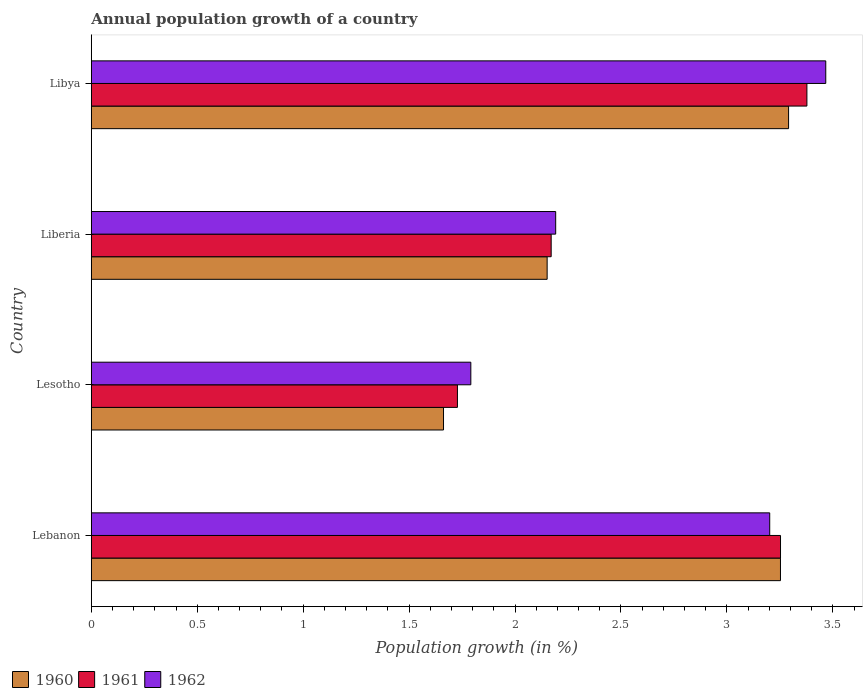How many groups of bars are there?
Your response must be concise. 4. Are the number of bars on each tick of the Y-axis equal?
Your answer should be very brief. Yes. How many bars are there on the 3rd tick from the top?
Keep it short and to the point. 3. What is the label of the 1st group of bars from the top?
Your response must be concise. Libya. In how many cases, is the number of bars for a given country not equal to the number of legend labels?
Your answer should be very brief. 0. What is the annual population growth in 1962 in Libya?
Keep it short and to the point. 3.47. Across all countries, what is the maximum annual population growth in 1961?
Offer a terse response. 3.38. Across all countries, what is the minimum annual population growth in 1961?
Give a very brief answer. 1.73. In which country was the annual population growth in 1961 maximum?
Give a very brief answer. Libya. In which country was the annual population growth in 1961 minimum?
Offer a very short reply. Lesotho. What is the total annual population growth in 1960 in the graph?
Provide a short and direct response. 10.36. What is the difference between the annual population growth in 1962 in Lebanon and that in Liberia?
Provide a succinct answer. 1.01. What is the difference between the annual population growth in 1961 in Liberia and the annual population growth in 1962 in Libya?
Keep it short and to the point. -1.3. What is the average annual population growth in 1962 per country?
Offer a terse response. 2.66. What is the difference between the annual population growth in 1961 and annual population growth in 1960 in Liberia?
Ensure brevity in your answer.  0.02. What is the ratio of the annual population growth in 1960 in Lesotho to that in Libya?
Offer a very short reply. 0.51. Is the difference between the annual population growth in 1961 in Lebanon and Liberia greater than the difference between the annual population growth in 1960 in Lebanon and Liberia?
Offer a terse response. No. What is the difference between the highest and the second highest annual population growth in 1960?
Provide a short and direct response. 0.04. What is the difference between the highest and the lowest annual population growth in 1960?
Your response must be concise. 1.63. In how many countries, is the annual population growth in 1961 greater than the average annual population growth in 1961 taken over all countries?
Your answer should be compact. 2. Is the sum of the annual population growth in 1962 in Lebanon and Liberia greater than the maximum annual population growth in 1961 across all countries?
Provide a short and direct response. Yes. What does the 3rd bar from the bottom in Libya represents?
Your answer should be very brief. 1962. Is it the case that in every country, the sum of the annual population growth in 1962 and annual population growth in 1960 is greater than the annual population growth in 1961?
Provide a short and direct response. Yes. How many bars are there?
Your answer should be compact. 12. Are all the bars in the graph horizontal?
Provide a short and direct response. Yes. Are the values on the major ticks of X-axis written in scientific E-notation?
Give a very brief answer. No. Does the graph contain any zero values?
Your answer should be compact. No. Does the graph contain grids?
Provide a succinct answer. No. Where does the legend appear in the graph?
Give a very brief answer. Bottom left. How are the legend labels stacked?
Your response must be concise. Horizontal. What is the title of the graph?
Give a very brief answer. Annual population growth of a country. What is the label or title of the X-axis?
Provide a succinct answer. Population growth (in %). What is the label or title of the Y-axis?
Your answer should be compact. Country. What is the Population growth (in %) of 1960 in Lebanon?
Offer a terse response. 3.25. What is the Population growth (in %) of 1961 in Lebanon?
Your response must be concise. 3.25. What is the Population growth (in %) of 1962 in Lebanon?
Your response must be concise. 3.2. What is the Population growth (in %) in 1960 in Lesotho?
Make the answer very short. 1.66. What is the Population growth (in %) of 1961 in Lesotho?
Your response must be concise. 1.73. What is the Population growth (in %) in 1962 in Lesotho?
Offer a very short reply. 1.79. What is the Population growth (in %) in 1960 in Liberia?
Give a very brief answer. 2.15. What is the Population growth (in %) of 1961 in Liberia?
Provide a succinct answer. 2.17. What is the Population growth (in %) in 1962 in Liberia?
Your answer should be very brief. 2.19. What is the Population growth (in %) in 1960 in Libya?
Give a very brief answer. 3.29. What is the Population growth (in %) of 1961 in Libya?
Offer a terse response. 3.38. What is the Population growth (in %) in 1962 in Libya?
Offer a terse response. 3.47. Across all countries, what is the maximum Population growth (in %) in 1960?
Offer a terse response. 3.29. Across all countries, what is the maximum Population growth (in %) of 1961?
Your response must be concise. 3.38. Across all countries, what is the maximum Population growth (in %) of 1962?
Provide a succinct answer. 3.47. Across all countries, what is the minimum Population growth (in %) in 1960?
Your response must be concise. 1.66. Across all countries, what is the minimum Population growth (in %) in 1961?
Ensure brevity in your answer.  1.73. Across all countries, what is the minimum Population growth (in %) of 1962?
Your response must be concise. 1.79. What is the total Population growth (in %) of 1960 in the graph?
Your answer should be compact. 10.36. What is the total Population growth (in %) in 1961 in the graph?
Keep it short and to the point. 10.53. What is the total Population growth (in %) in 1962 in the graph?
Your answer should be compact. 10.65. What is the difference between the Population growth (in %) of 1960 in Lebanon and that in Lesotho?
Your answer should be compact. 1.59. What is the difference between the Population growth (in %) of 1961 in Lebanon and that in Lesotho?
Ensure brevity in your answer.  1.52. What is the difference between the Population growth (in %) in 1962 in Lebanon and that in Lesotho?
Provide a succinct answer. 1.41. What is the difference between the Population growth (in %) in 1960 in Lebanon and that in Liberia?
Your answer should be very brief. 1.1. What is the difference between the Population growth (in %) of 1961 in Lebanon and that in Liberia?
Give a very brief answer. 1.08. What is the difference between the Population growth (in %) of 1962 in Lebanon and that in Liberia?
Offer a terse response. 1.01. What is the difference between the Population growth (in %) of 1960 in Lebanon and that in Libya?
Ensure brevity in your answer.  -0.04. What is the difference between the Population growth (in %) of 1961 in Lebanon and that in Libya?
Provide a succinct answer. -0.12. What is the difference between the Population growth (in %) of 1962 in Lebanon and that in Libya?
Keep it short and to the point. -0.26. What is the difference between the Population growth (in %) of 1960 in Lesotho and that in Liberia?
Your response must be concise. -0.49. What is the difference between the Population growth (in %) of 1961 in Lesotho and that in Liberia?
Offer a terse response. -0.44. What is the difference between the Population growth (in %) in 1962 in Lesotho and that in Liberia?
Provide a succinct answer. -0.4. What is the difference between the Population growth (in %) of 1960 in Lesotho and that in Libya?
Provide a short and direct response. -1.63. What is the difference between the Population growth (in %) of 1961 in Lesotho and that in Libya?
Offer a very short reply. -1.65. What is the difference between the Population growth (in %) of 1962 in Lesotho and that in Libya?
Your answer should be very brief. -1.68. What is the difference between the Population growth (in %) in 1960 in Liberia and that in Libya?
Give a very brief answer. -1.14. What is the difference between the Population growth (in %) in 1961 in Liberia and that in Libya?
Provide a short and direct response. -1.21. What is the difference between the Population growth (in %) in 1962 in Liberia and that in Libya?
Offer a very short reply. -1.27. What is the difference between the Population growth (in %) in 1960 in Lebanon and the Population growth (in %) in 1961 in Lesotho?
Give a very brief answer. 1.52. What is the difference between the Population growth (in %) of 1960 in Lebanon and the Population growth (in %) of 1962 in Lesotho?
Offer a very short reply. 1.46. What is the difference between the Population growth (in %) of 1961 in Lebanon and the Population growth (in %) of 1962 in Lesotho?
Ensure brevity in your answer.  1.46. What is the difference between the Population growth (in %) in 1960 in Lebanon and the Population growth (in %) in 1961 in Liberia?
Offer a terse response. 1.08. What is the difference between the Population growth (in %) in 1960 in Lebanon and the Population growth (in %) in 1962 in Liberia?
Give a very brief answer. 1.06. What is the difference between the Population growth (in %) in 1961 in Lebanon and the Population growth (in %) in 1962 in Liberia?
Offer a very short reply. 1.06. What is the difference between the Population growth (in %) in 1960 in Lebanon and the Population growth (in %) in 1961 in Libya?
Make the answer very short. -0.12. What is the difference between the Population growth (in %) in 1960 in Lebanon and the Population growth (in %) in 1962 in Libya?
Your answer should be compact. -0.21. What is the difference between the Population growth (in %) of 1961 in Lebanon and the Population growth (in %) of 1962 in Libya?
Make the answer very short. -0.21. What is the difference between the Population growth (in %) of 1960 in Lesotho and the Population growth (in %) of 1961 in Liberia?
Your answer should be compact. -0.51. What is the difference between the Population growth (in %) in 1960 in Lesotho and the Population growth (in %) in 1962 in Liberia?
Ensure brevity in your answer.  -0.53. What is the difference between the Population growth (in %) of 1961 in Lesotho and the Population growth (in %) of 1962 in Liberia?
Give a very brief answer. -0.46. What is the difference between the Population growth (in %) of 1960 in Lesotho and the Population growth (in %) of 1961 in Libya?
Provide a short and direct response. -1.72. What is the difference between the Population growth (in %) in 1960 in Lesotho and the Population growth (in %) in 1962 in Libya?
Ensure brevity in your answer.  -1.8. What is the difference between the Population growth (in %) in 1961 in Lesotho and the Population growth (in %) in 1962 in Libya?
Provide a short and direct response. -1.74. What is the difference between the Population growth (in %) of 1960 in Liberia and the Population growth (in %) of 1961 in Libya?
Provide a short and direct response. -1.23. What is the difference between the Population growth (in %) of 1960 in Liberia and the Population growth (in %) of 1962 in Libya?
Your answer should be very brief. -1.31. What is the difference between the Population growth (in %) in 1961 in Liberia and the Population growth (in %) in 1962 in Libya?
Provide a succinct answer. -1.3. What is the average Population growth (in %) in 1960 per country?
Offer a very short reply. 2.59. What is the average Population growth (in %) in 1961 per country?
Make the answer very short. 2.63. What is the average Population growth (in %) in 1962 per country?
Your response must be concise. 2.66. What is the difference between the Population growth (in %) of 1960 and Population growth (in %) of 1961 in Lebanon?
Ensure brevity in your answer.  -0. What is the difference between the Population growth (in %) in 1960 and Population growth (in %) in 1962 in Lebanon?
Provide a short and direct response. 0.05. What is the difference between the Population growth (in %) in 1961 and Population growth (in %) in 1962 in Lebanon?
Your answer should be very brief. 0.05. What is the difference between the Population growth (in %) of 1960 and Population growth (in %) of 1961 in Lesotho?
Your answer should be compact. -0.07. What is the difference between the Population growth (in %) in 1960 and Population growth (in %) in 1962 in Lesotho?
Your response must be concise. -0.13. What is the difference between the Population growth (in %) in 1961 and Population growth (in %) in 1962 in Lesotho?
Give a very brief answer. -0.06. What is the difference between the Population growth (in %) of 1960 and Population growth (in %) of 1961 in Liberia?
Make the answer very short. -0.02. What is the difference between the Population growth (in %) in 1960 and Population growth (in %) in 1962 in Liberia?
Make the answer very short. -0.04. What is the difference between the Population growth (in %) in 1961 and Population growth (in %) in 1962 in Liberia?
Make the answer very short. -0.02. What is the difference between the Population growth (in %) of 1960 and Population growth (in %) of 1961 in Libya?
Your answer should be compact. -0.09. What is the difference between the Population growth (in %) of 1960 and Population growth (in %) of 1962 in Libya?
Your response must be concise. -0.18. What is the difference between the Population growth (in %) of 1961 and Population growth (in %) of 1962 in Libya?
Offer a terse response. -0.09. What is the ratio of the Population growth (in %) in 1960 in Lebanon to that in Lesotho?
Offer a terse response. 1.96. What is the ratio of the Population growth (in %) in 1961 in Lebanon to that in Lesotho?
Provide a short and direct response. 1.88. What is the ratio of the Population growth (in %) of 1962 in Lebanon to that in Lesotho?
Make the answer very short. 1.79. What is the ratio of the Population growth (in %) in 1960 in Lebanon to that in Liberia?
Make the answer very short. 1.51. What is the ratio of the Population growth (in %) of 1961 in Lebanon to that in Liberia?
Keep it short and to the point. 1.5. What is the ratio of the Population growth (in %) of 1962 in Lebanon to that in Liberia?
Your answer should be very brief. 1.46. What is the ratio of the Population growth (in %) in 1960 in Lebanon to that in Libya?
Your answer should be compact. 0.99. What is the ratio of the Population growth (in %) in 1961 in Lebanon to that in Libya?
Your answer should be compact. 0.96. What is the ratio of the Population growth (in %) of 1962 in Lebanon to that in Libya?
Offer a very short reply. 0.92. What is the ratio of the Population growth (in %) in 1960 in Lesotho to that in Liberia?
Ensure brevity in your answer.  0.77. What is the ratio of the Population growth (in %) of 1961 in Lesotho to that in Liberia?
Your response must be concise. 0.8. What is the ratio of the Population growth (in %) of 1962 in Lesotho to that in Liberia?
Give a very brief answer. 0.82. What is the ratio of the Population growth (in %) of 1960 in Lesotho to that in Libya?
Make the answer very short. 0.51. What is the ratio of the Population growth (in %) of 1961 in Lesotho to that in Libya?
Provide a succinct answer. 0.51. What is the ratio of the Population growth (in %) of 1962 in Lesotho to that in Libya?
Ensure brevity in your answer.  0.52. What is the ratio of the Population growth (in %) in 1960 in Liberia to that in Libya?
Your answer should be very brief. 0.65. What is the ratio of the Population growth (in %) in 1961 in Liberia to that in Libya?
Your answer should be very brief. 0.64. What is the ratio of the Population growth (in %) of 1962 in Liberia to that in Libya?
Your answer should be compact. 0.63. What is the difference between the highest and the second highest Population growth (in %) in 1960?
Offer a terse response. 0.04. What is the difference between the highest and the second highest Population growth (in %) in 1961?
Ensure brevity in your answer.  0.12. What is the difference between the highest and the second highest Population growth (in %) of 1962?
Keep it short and to the point. 0.26. What is the difference between the highest and the lowest Population growth (in %) of 1960?
Make the answer very short. 1.63. What is the difference between the highest and the lowest Population growth (in %) in 1961?
Offer a terse response. 1.65. What is the difference between the highest and the lowest Population growth (in %) in 1962?
Offer a terse response. 1.68. 